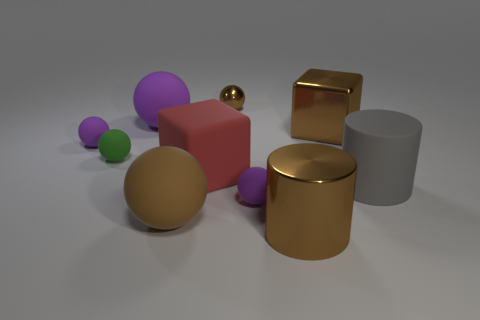How many purple balls must be subtracted to get 1 purple balls? 2 Subtract all red blocks. How many purple balls are left? 3 Subtract all green spheres. How many spheres are left? 5 Subtract all big rubber balls. How many balls are left? 4 Subtract all green balls. Subtract all green cylinders. How many balls are left? 5 Subtract all balls. How many objects are left? 4 Add 1 big gray things. How many big gray things exist? 2 Subtract 0 cyan blocks. How many objects are left? 10 Subtract all yellow matte blocks. Subtract all big purple matte spheres. How many objects are left? 9 Add 7 tiny metallic objects. How many tiny metallic objects are left? 8 